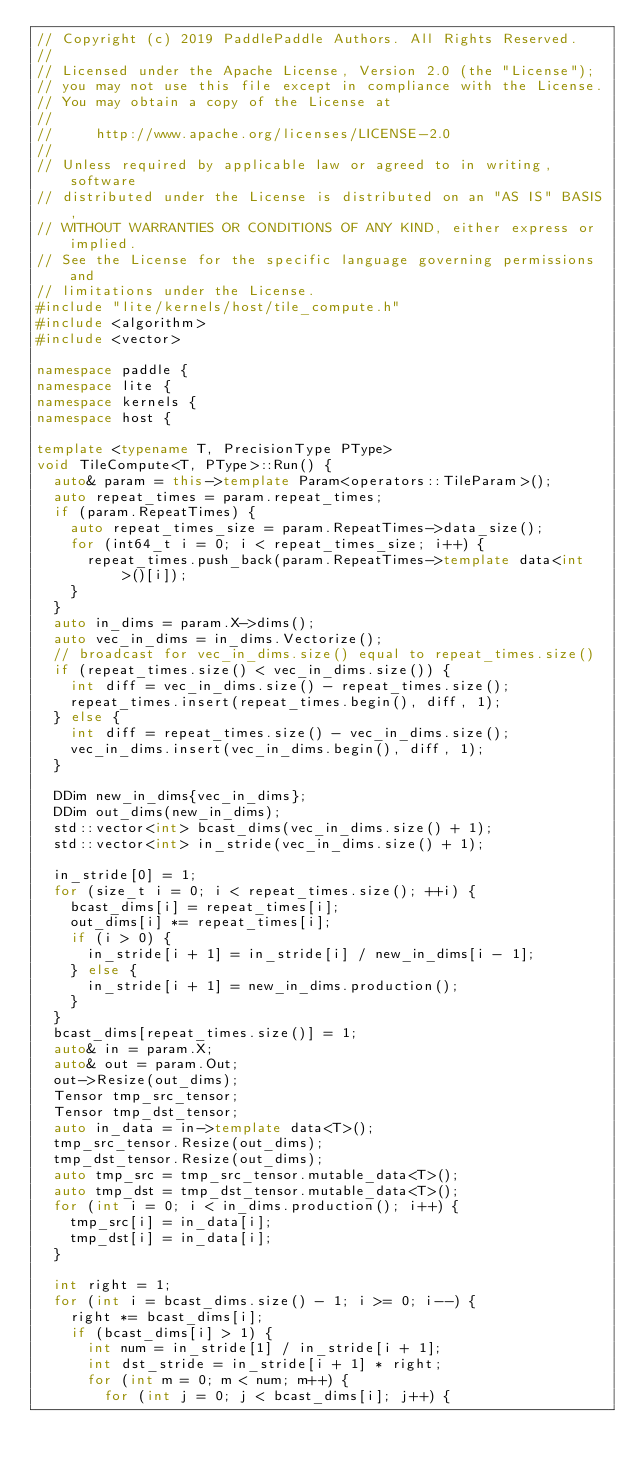<code> <loc_0><loc_0><loc_500><loc_500><_C++_>// Copyright (c) 2019 PaddlePaddle Authors. All Rights Reserved.
//
// Licensed under the Apache License, Version 2.0 (the "License");
// you may not use this file except in compliance with the License.
// You may obtain a copy of the License at
//
//     http://www.apache.org/licenses/LICENSE-2.0
//
// Unless required by applicable law or agreed to in writing, software
// distributed under the License is distributed on an "AS IS" BASIS,
// WITHOUT WARRANTIES OR CONDITIONS OF ANY KIND, either express or implied.
// See the License for the specific language governing permissions and
// limitations under the License.
#include "lite/kernels/host/tile_compute.h"
#include <algorithm>
#include <vector>

namespace paddle {
namespace lite {
namespace kernels {
namespace host {

template <typename T, PrecisionType PType>
void TileCompute<T, PType>::Run() {
  auto& param = this->template Param<operators::TileParam>();
  auto repeat_times = param.repeat_times;
  if (param.RepeatTimes) {
    auto repeat_times_size = param.RepeatTimes->data_size();
    for (int64_t i = 0; i < repeat_times_size; i++) {
      repeat_times.push_back(param.RepeatTimes->template data<int>()[i]);
    }
  }
  auto in_dims = param.X->dims();
  auto vec_in_dims = in_dims.Vectorize();
  // broadcast for vec_in_dims.size() equal to repeat_times.size()
  if (repeat_times.size() < vec_in_dims.size()) {
    int diff = vec_in_dims.size() - repeat_times.size();
    repeat_times.insert(repeat_times.begin(), diff, 1);
  } else {
    int diff = repeat_times.size() - vec_in_dims.size();
    vec_in_dims.insert(vec_in_dims.begin(), diff, 1);
  }

  DDim new_in_dims{vec_in_dims};
  DDim out_dims(new_in_dims);
  std::vector<int> bcast_dims(vec_in_dims.size() + 1);
  std::vector<int> in_stride(vec_in_dims.size() + 1);

  in_stride[0] = 1;
  for (size_t i = 0; i < repeat_times.size(); ++i) {
    bcast_dims[i] = repeat_times[i];
    out_dims[i] *= repeat_times[i];
    if (i > 0) {
      in_stride[i + 1] = in_stride[i] / new_in_dims[i - 1];
    } else {
      in_stride[i + 1] = new_in_dims.production();
    }
  }
  bcast_dims[repeat_times.size()] = 1;
  auto& in = param.X;
  auto& out = param.Out;
  out->Resize(out_dims);
  Tensor tmp_src_tensor;
  Tensor tmp_dst_tensor;
  auto in_data = in->template data<T>();
  tmp_src_tensor.Resize(out_dims);
  tmp_dst_tensor.Resize(out_dims);
  auto tmp_src = tmp_src_tensor.mutable_data<T>();
  auto tmp_dst = tmp_dst_tensor.mutable_data<T>();
  for (int i = 0; i < in_dims.production(); i++) {
    tmp_src[i] = in_data[i];
    tmp_dst[i] = in_data[i];
  }

  int right = 1;
  for (int i = bcast_dims.size() - 1; i >= 0; i--) {
    right *= bcast_dims[i];
    if (bcast_dims[i] > 1) {
      int num = in_stride[1] / in_stride[i + 1];
      int dst_stride = in_stride[i + 1] * right;
      for (int m = 0; m < num; m++) {
        for (int j = 0; j < bcast_dims[i]; j++) {</code> 